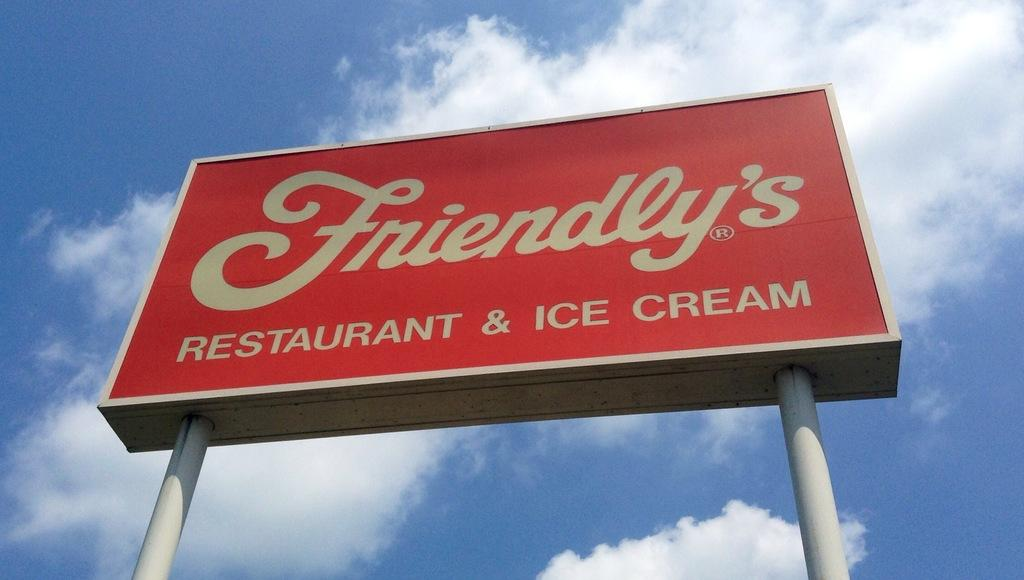Provide a one-sentence caption for the provided image. A Friendly's restaurant sign towers overhead in front of a blue sky. 